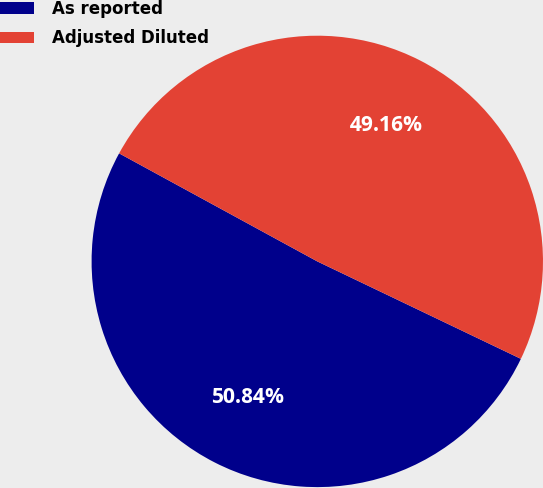<chart> <loc_0><loc_0><loc_500><loc_500><pie_chart><fcel>As reported<fcel>Adjusted Diluted<nl><fcel>50.84%<fcel>49.16%<nl></chart> 